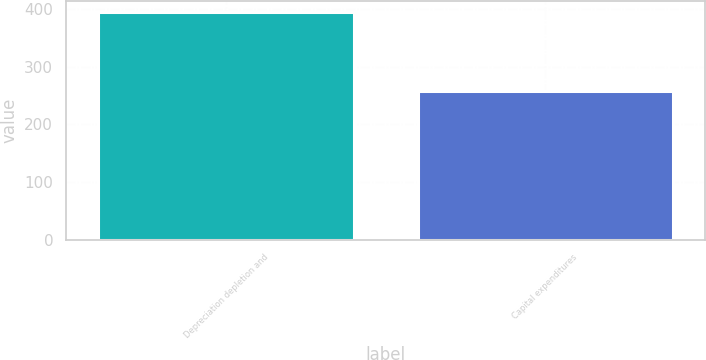Convert chart. <chart><loc_0><loc_0><loc_500><loc_500><bar_chart><fcel>Depreciation depletion and<fcel>Capital expenditures<nl><fcel>394.8<fcel>258.1<nl></chart> 